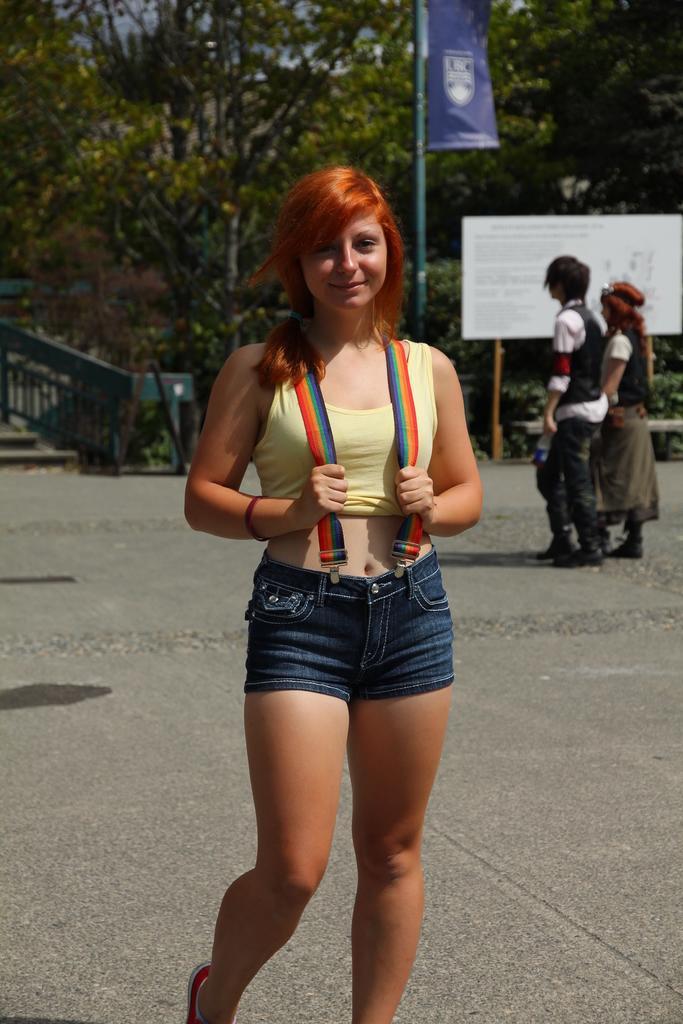Could you give a brief overview of what you see in this image? In this image there is a person standing and smiling, and in the background there are two persons walking , boards with the poles, trees. 